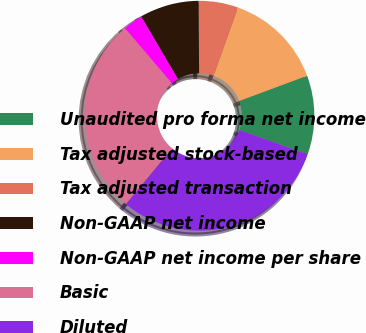<chart> <loc_0><loc_0><loc_500><loc_500><pie_chart><fcel>Unaudited pro forma net income<fcel>Tax adjusted stock-based<fcel>Tax adjusted transaction<fcel>Non-GAAP net income<fcel>Non-GAAP net income per share<fcel>Basic<fcel>Diluted<nl><fcel>11.11%<fcel>13.89%<fcel>5.56%<fcel>8.33%<fcel>2.78%<fcel>27.78%<fcel>30.56%<nl></chart> 